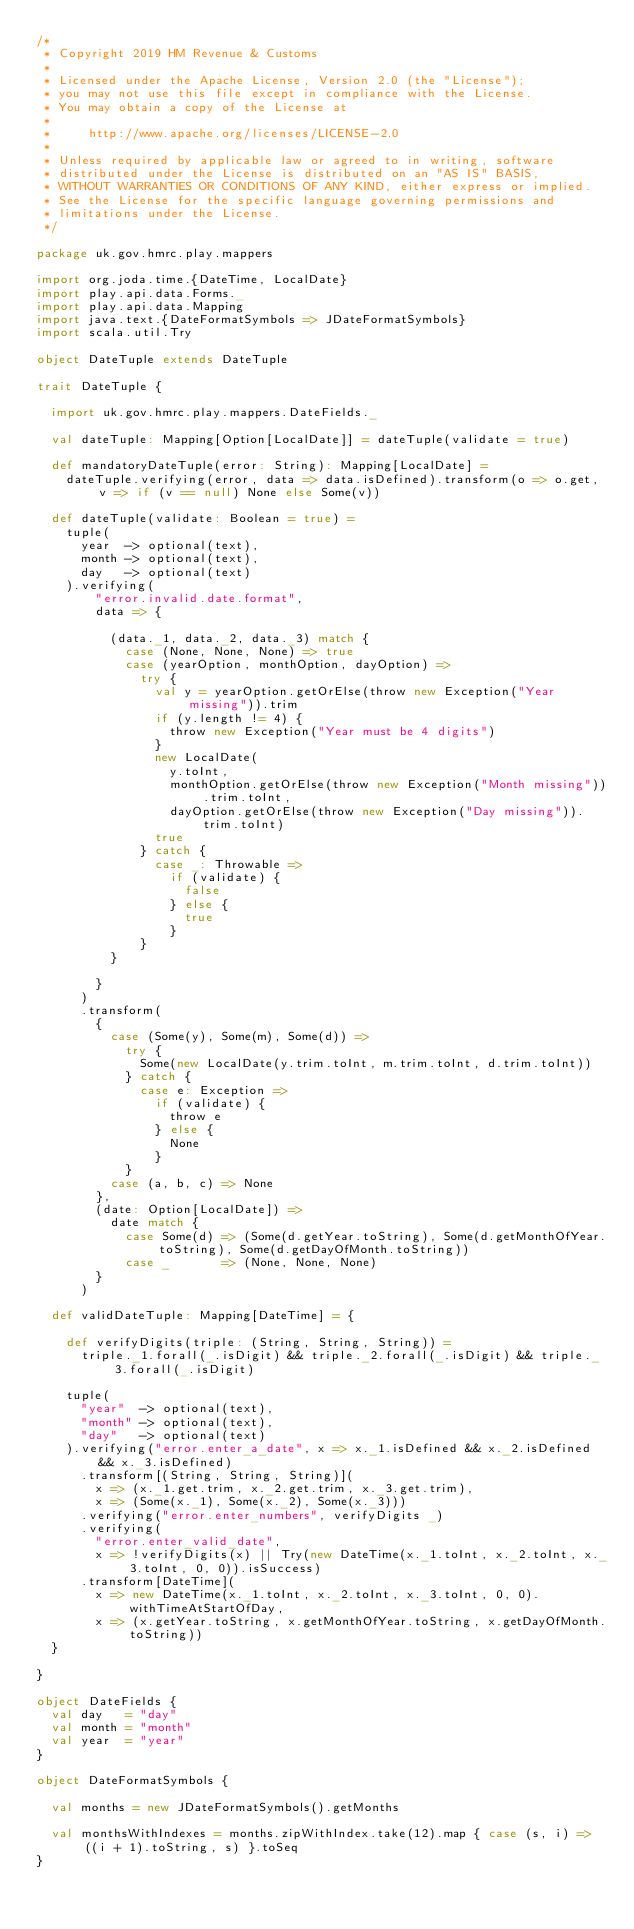<code> <loc_0><loc_0><loc_500><loc_500><_Scala_>/*
 * Copyright 2019 HM Revenue & Customs
 *
 * Licensed under the Apache License, Version 2.0 (the "License");
 * you may not use this file except in compliance with the License.
 * You may obtain a copy of the License at
 *
 *     http://www.apache.org/licenses/LICENSE-2.0
 *
 * Unless required by applicable law or agreed to in writing, software
 * distributed under the License is distributed on an "AS IS" BASIS,
 * WITHOUT WARRANTIES OR CONDITIONS OF ANY KIND, either express or implied.
 * See the License for the specific language governing permissions and
 * limitations under the License.
 */

package uk.gov.hmrc.play.mappers

import org.joda.time.{DateTime, LocalDate}
import play.api.data.Forms._
import play.api.data.Mapping
import java.text.{DateFormatSymbols => JDateFormatSymbols}
import scala.util.Try

object DateTuple extends DateTuple

trait DateTuple {

  import uk.gov.hmrc.play.mappers.DateFields._

  val dateTuple: Mapping[Option[LocalDate]] = dateTuple(validate = true)

  def mandatoryDateTuple(error: String): Mapping[LocalDate] =
    dateTuple.verifying(error, data => data.isDefined).transform(o => o.get, v => if (v == null) None else Some(v))

  def dateTuple(validate: Boolean = true) =
    tuple(
      year  -> optional(text),
      month -> optional(text),
      day   -> optional(text)
    ).verifying(
        "error.invalid.date.format",
        data => {

          (data._1, data._2, data._3) match {
            case (None, None, None) => true
            case (yearOption, monthOption, dayOption) =>
              try {
                val y = yearOption.getOrElse(throw new Exception("Year missing")).trim
                if (y.length != 4) {
                  throw new Exception("Year must be 4 digits")
                }
                new LocalDate(
                  y.toInt,
                  monthOption.getOrElse(throw new Exception("Month missing")).trim.toInt,
                  dayOption.getOrElse(throw new Exception("Day missing")).trim.toInt)
                true
              } catch {
                case _: Throwable =>
                  if (validate) {
                    false
                  } else {
                    true
                  }
              }
          }

        }
      )
      .transform(
        {
          case (Some(y), Some(m), Some(d)) =>
            try {
              Some(new LocalDate(y.trim.toInt, m.trim.toInt, d.trim.toInt))
            } catch {
              case e: Exception =>
                if (validate) {
                  throw e
                } else {
                  None
                }
            }
          case (a, b, c) => None
        },
        (date: Option[LocalDate]) =>
          date match {
            case Some(d) => (Some(d.getYear.toString), Some(d.getMonthOfYear.toString), Some(d.getDayOfMonth.toString))
            case _       => (None, None, None)
        }
      )

  def validDateTuple: Mapping[DateTime] = {

    def verifyDigits(triple: (String, String, String)) =
      triple._1.forall(_.isDigit) && triple._2.forall(_.isDigit) && triple._3.forall(_.isDigit)

    tuple(
      "year"  -> optional(text),
      "month" -> optional(text),
      "day"   -> optional(text)
    ).verifying("error.enter_a_date", x => x._1.isDefined && x._2.isDefined && x._3.isDefined)
      .transform[(String, String, String)](
        x => (x._1.get.trim, x._2.get.trim, x._3.get.trim),
        x => (Some(x._1), Some(x._2), Some(x._3)))
      .verifying("error.enter_numbers", verifyDigits _)
      .verifying(
        "error.enter_valid_date",
        x => !verifyDigits(x) || Try(new DateTime(x._1.toInt, x._2.toInt, x._3.toInt, 0, 0)).isSuccess)
      .transform[DateTime](
        x => new DateTime(x._1.toInt, x._2.toInt, x._3.toInt, 0, 0).withTimeAtStartOfDay,
        x => (x.getYear.toString, x.getMonthOfYear.toString, x.getDayOfMonth.toString))
  }

}

object DateFields {
  val day   = "day"
  val month = "month"
  val year  = "year"
}

object DateFormatSymbols {

  val months = new JDateFormatSymbols().getMonths

  val monthsWithIndexes = months.zipWithIndex.take(12).map { case (s, i) => ((i + 1).toString, s) }.toSeq
}
</code> 